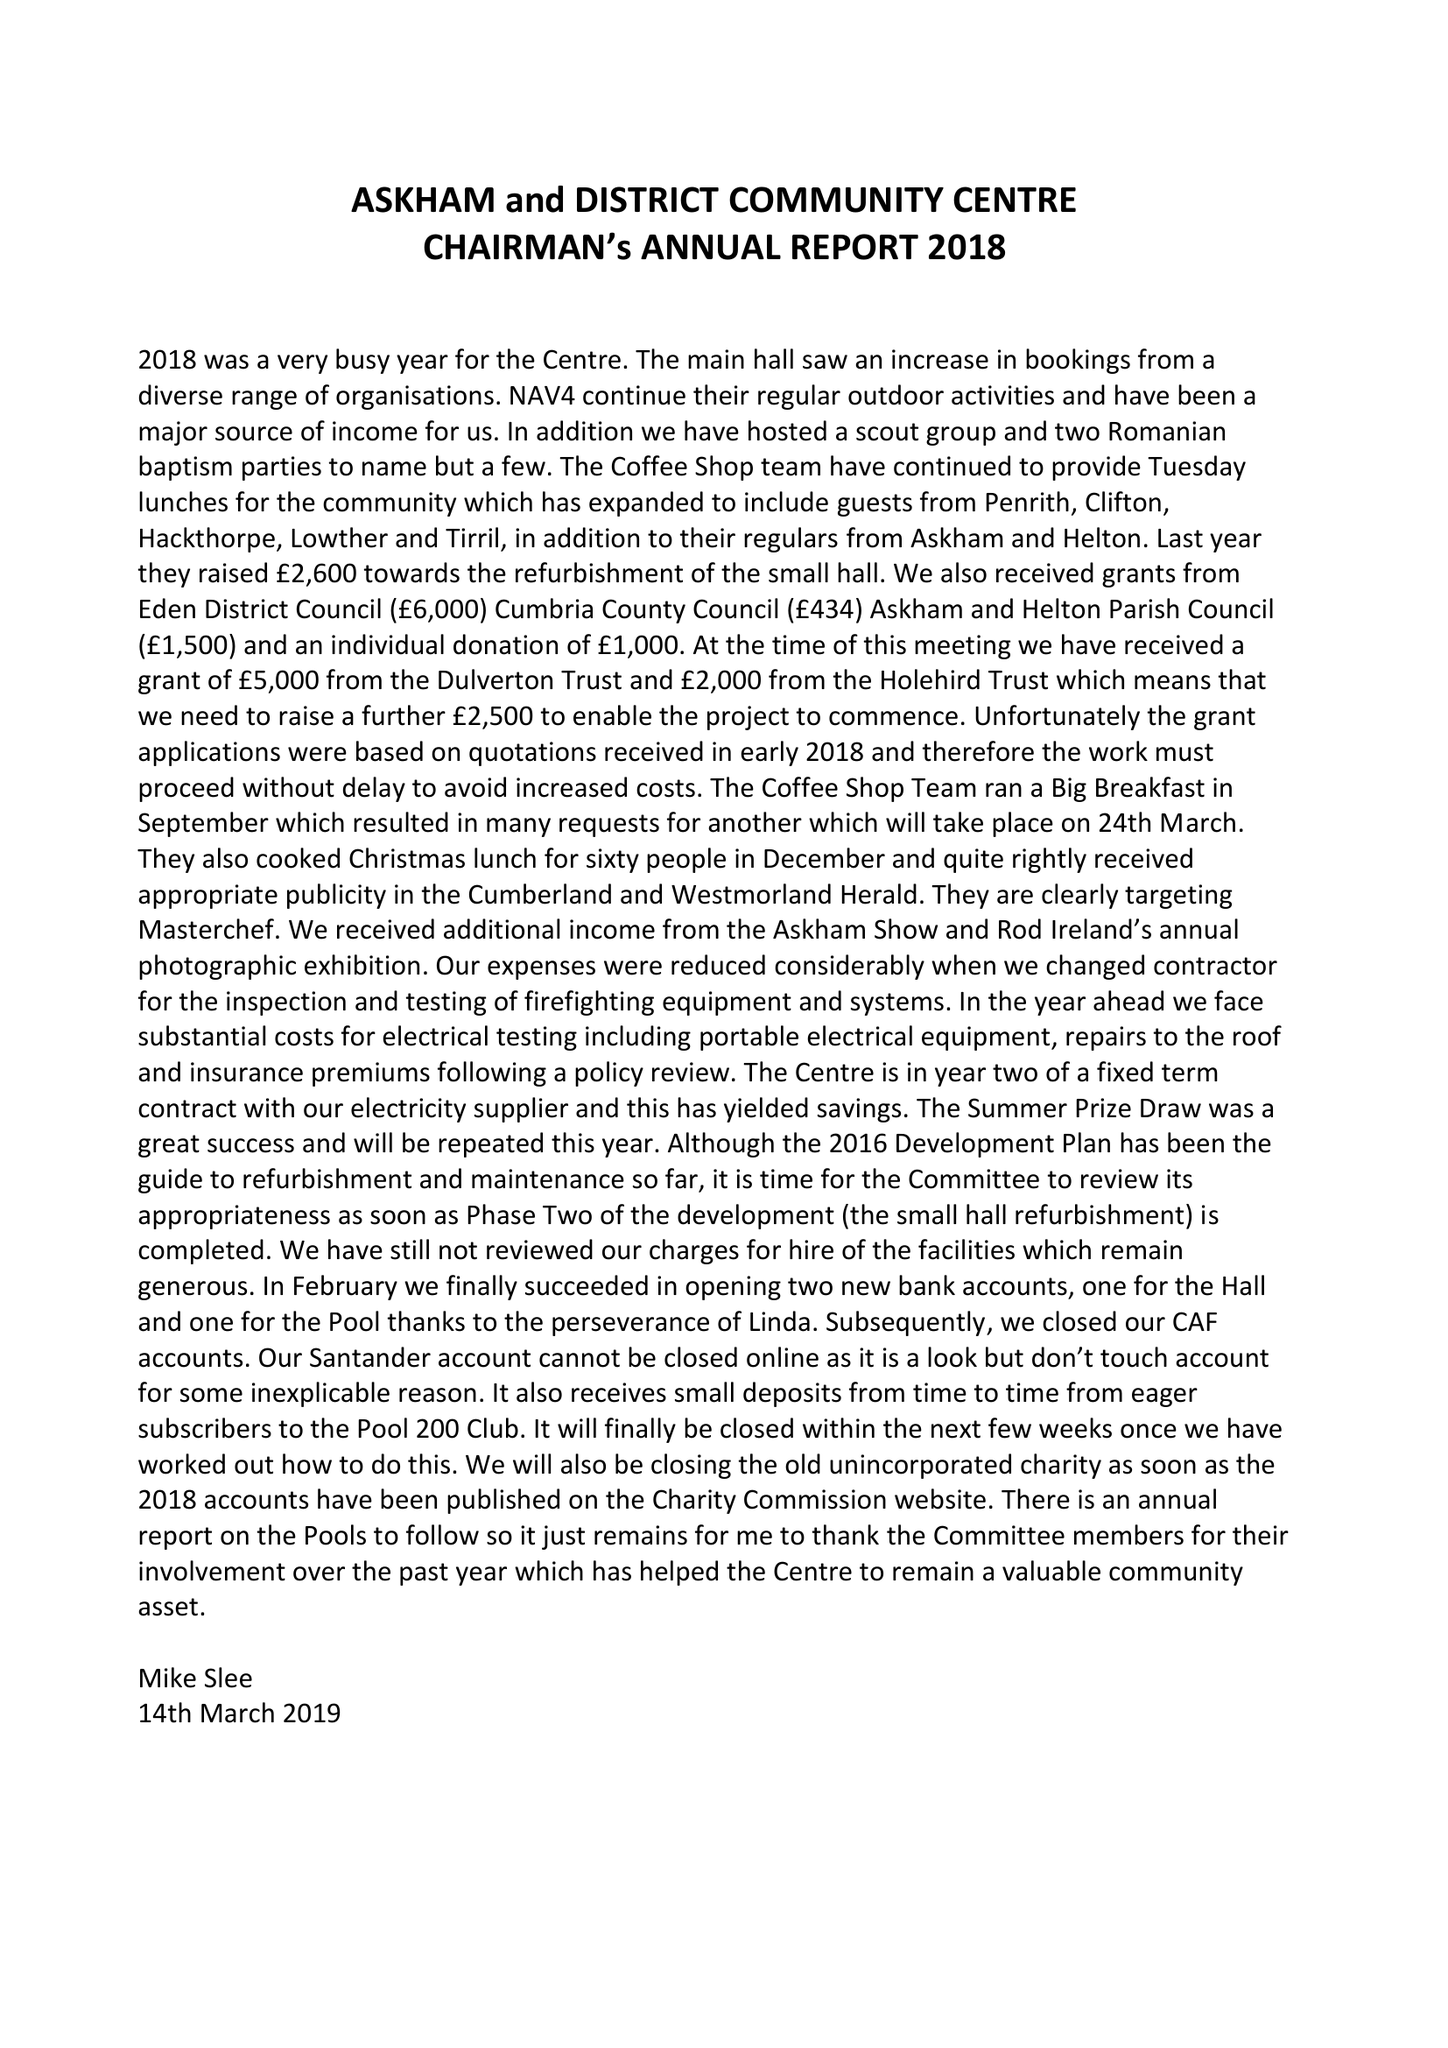What is the value for the address__postcode?
Answer the question using a single word or phrase. CA10 2PF 